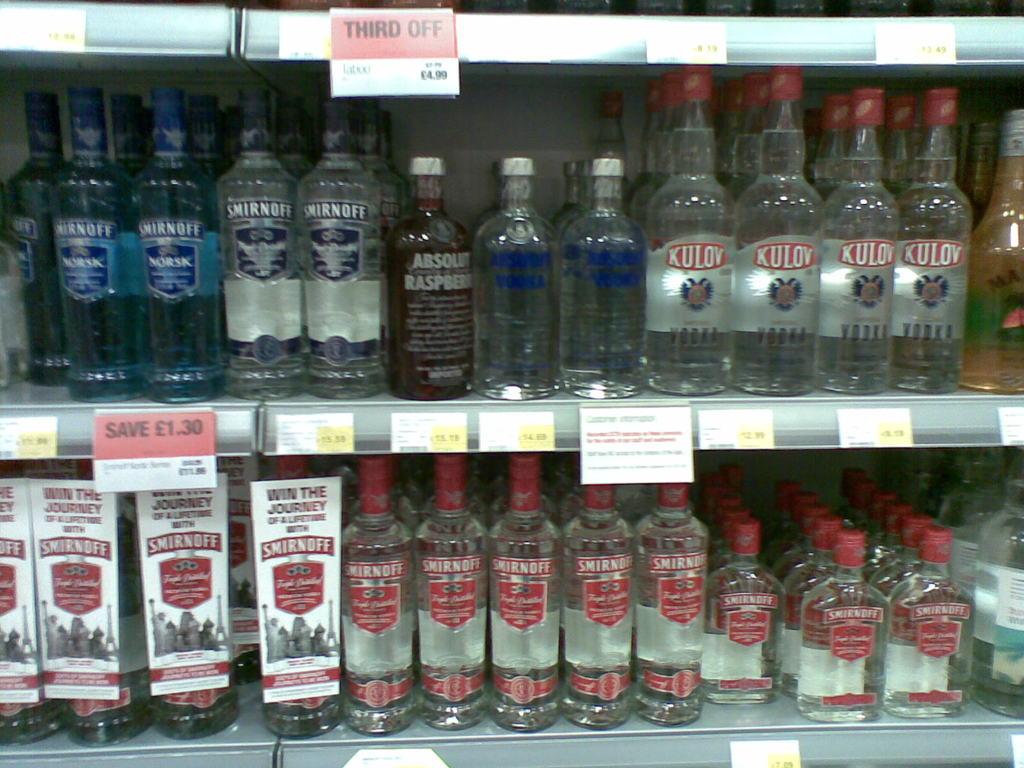How much do you save on the blue smirnoff?
Provide a succinct answer. 1.30. What type of alcohol are these?
Keep it short and to the point. Vodka. 